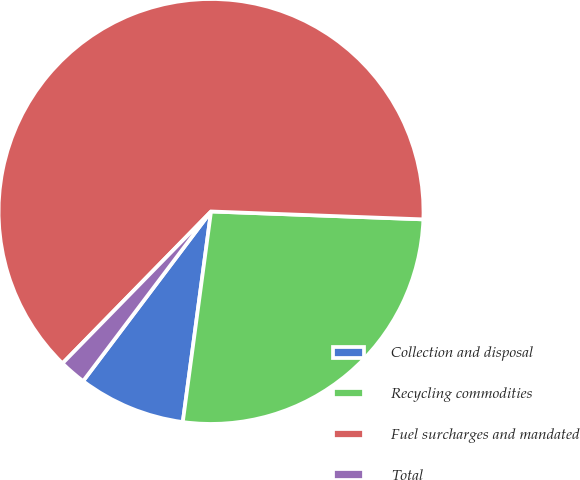Convert chart. <chart><loc_0><loc_0><loc_500><loc_500><pie_chart><fcel>Collection and disposal<fcel>Recycling commodities<fcel>Fuel surcharges and mandated<fcel>Total<nl><fcel>8.16%<fcel>26.53%<fcel>63.27%<fcel>2.04%<nl></chart> 